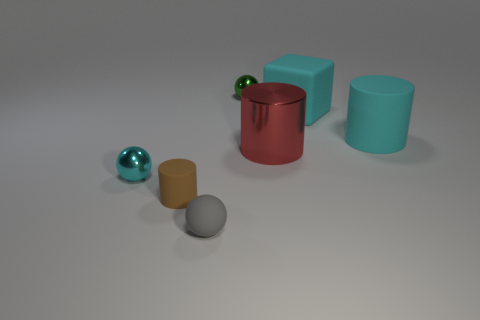Does the lighting in the image suggest a specific time of day? The lighting in the image appears to be neutral and diffuse, lacking any strong shadows or highlights that would indicate a specific time of day. It seems more indicative of a controlled studio lighting environment rather than natural light. 